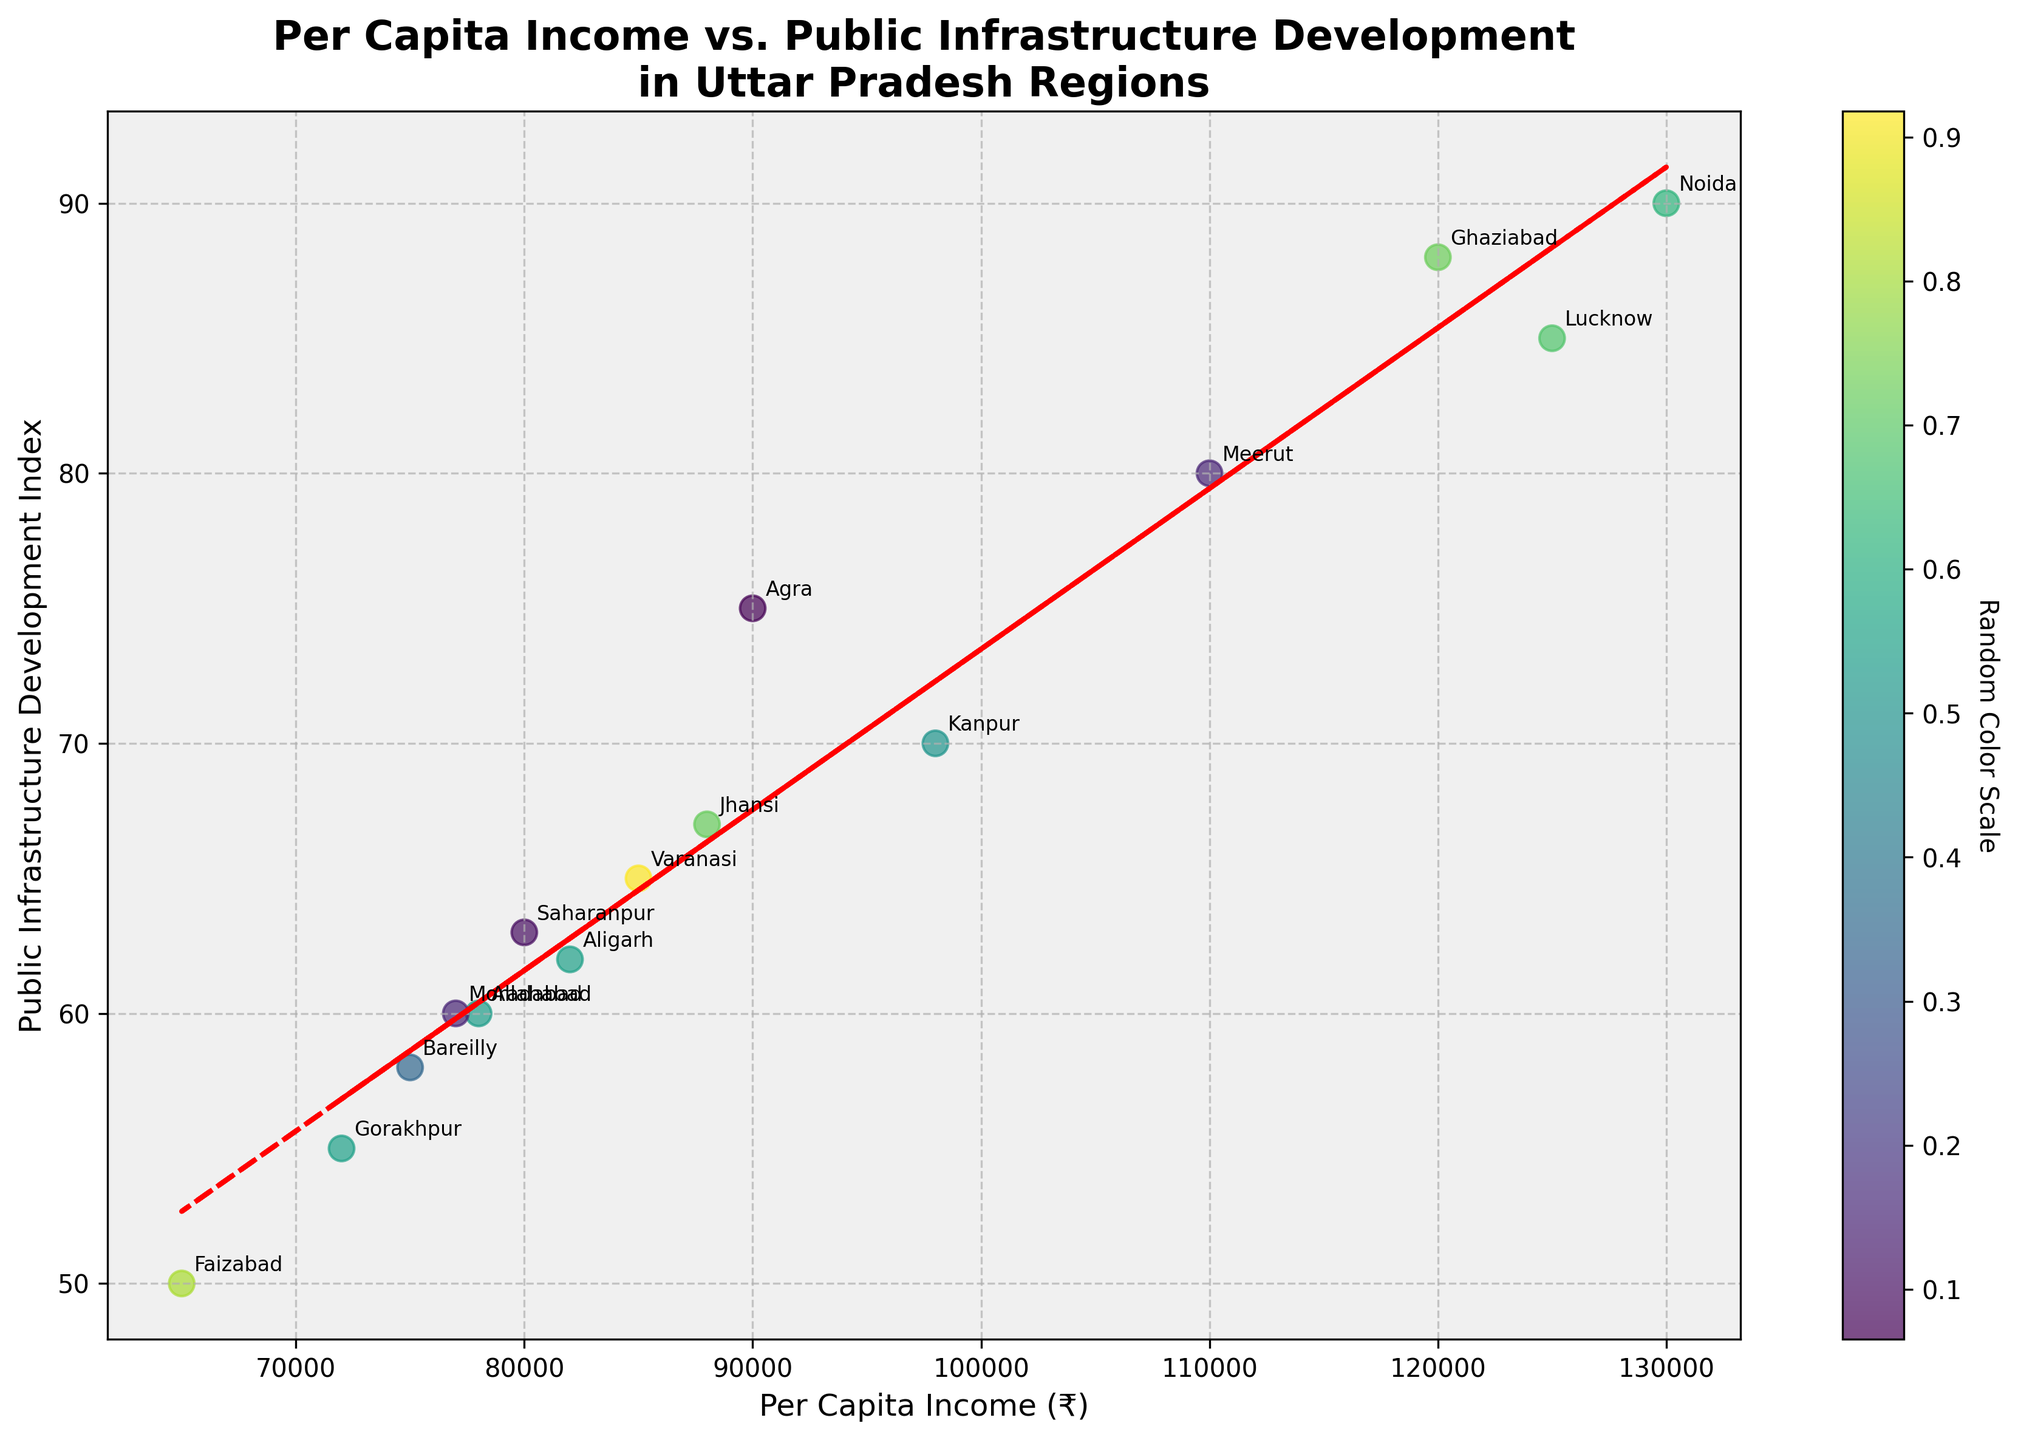What is the title of the figure? The title of the figure is prominently displayed at the top. It states: "Per Capita Income vs. Public Infrastructure Development in Uttar Pradesh Regions."
Answer: Per Capita Income vs. Public Infrastructure Development in Uttar Pradesh Regions How many regions are plotted on the figure? Each data point on the plot corresponds to a region. Counting the data points gives us the total number of regions.
Answer: 15 Which region has the highest per capita income? By looking at the data points on the x-axis, the farthest point to the right represents the highest per capita income. The region labeled at this point is Noida.
Answer: Noida What is the relationship between per capita income and public infrastructure development as shown by the trend line? The trend line is a red dashed line, and it shows the general trend of the data points. It has a positive slope, indicating that as the per capita income increases, the public infrastructure development index also tends to increase.
Answer: Positive relationship Which region has the lowest public infrastructure development index? By looking at the data points on the y-axis, the lowest point represents the lowest public infrastructure development index. The region labeled at this point is Faizabad.
Answer: Faizabad Compare the per capita income of Kanpur and Meerut. Which one is higher and by how much? Kanpur's per capita income is ₹98,000, and Meerut's is ₹110,000. Subtracting Kanpur's income from Meerut's gives the difference.
Answer: ₹12,000 What is the average public infrastructure development index of all the regions? Summing all the public infrastructure development indices and dividing by the number of regions gives the average. Calculation: (85+70+65+60+55+75+80+90+88+62+58+67+50+60+63)/15 = 70.1
Answer: 70.1 Identify the two regions nearest to the trend line. Regions closest to the trend line have data points that lie near the red dashed line. By observing, we can see that Varanasi and Allahabad are the closest.
Answer: Varanasi and Allahabad Does any region have a public infrastructure development index above 85 but a per capita income below ₹120,000? If yes, name them. By scanning the figure, we see that the regions with public infrastructure development indices above 85 are Lucknow and Ghaziabad. Out of these, Lucknow has a per capita income below ₹120,000.
Answer: Lucknow Is there a region with both per capita income and public infrastructure development index below the median values of their respective axes? Name it if so. Median per capita income = ₹85,000 (Varanasi) and median public infrastructure development index = 65 (Varanasi). Scanning the region names, we can confirm. It is Saharanpur.
Answer: Saharanpur 